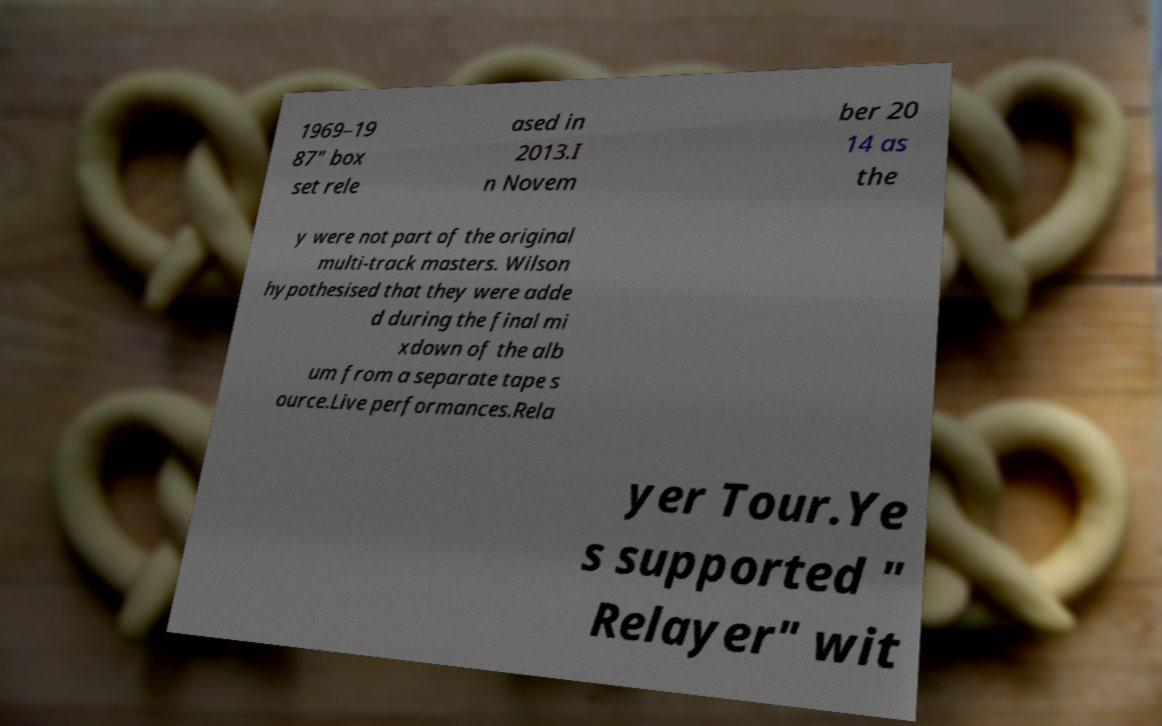Can you accurately transcribe the text from the provided image for me? 1969–19 87" box set rele ased in 2013.I n Novem ber 20 14 as the y were not part of the original multi-track masters. Wilson hypothesised that they were adde d during the final mi xdown of the alb um from a separate tape s ource.Live performances.Rela yer Tour.Ye s supported " Relayer" wit 